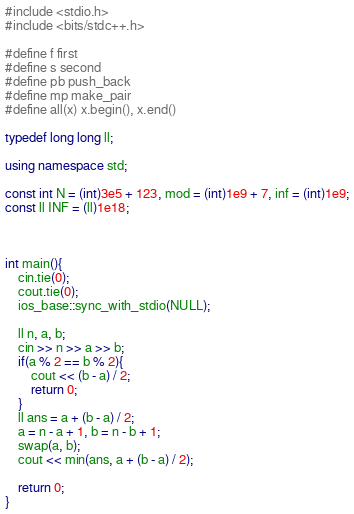Convert code to text. <code><loc_0><loc_0><loc_500><loc_500><_C++_>#include <stdio.h>
#include <bits/stdc++.h>

#define f first
#define s second
#define pb push_back
#define mp make_pair
#define all(x) x.begin(), x.end()

typedef long long ll;

using namespace std;

const int N = (int)3e5 + 123, mod = (int)1e9 + 7, inf = (int)1e9;
const ll INF = (ll)1e18;



int main(){
	cin.tie(0);
	cout.tie(0);
	ios_base::sync_with_stdio(NULL);

	ll n, a, b;
	cin >> n >> a >> b;
	if(a % 2 == b % 2){
		cout << (b - a) / 2;
		return 0;
	}
	ll ans = a + (b - a) / 2;
	a = n - a + 1, b = n - b + 1;
	swap(a, b);
	cout << min(ans, a + (b - a) / 2);

	return 0;
}</code> 